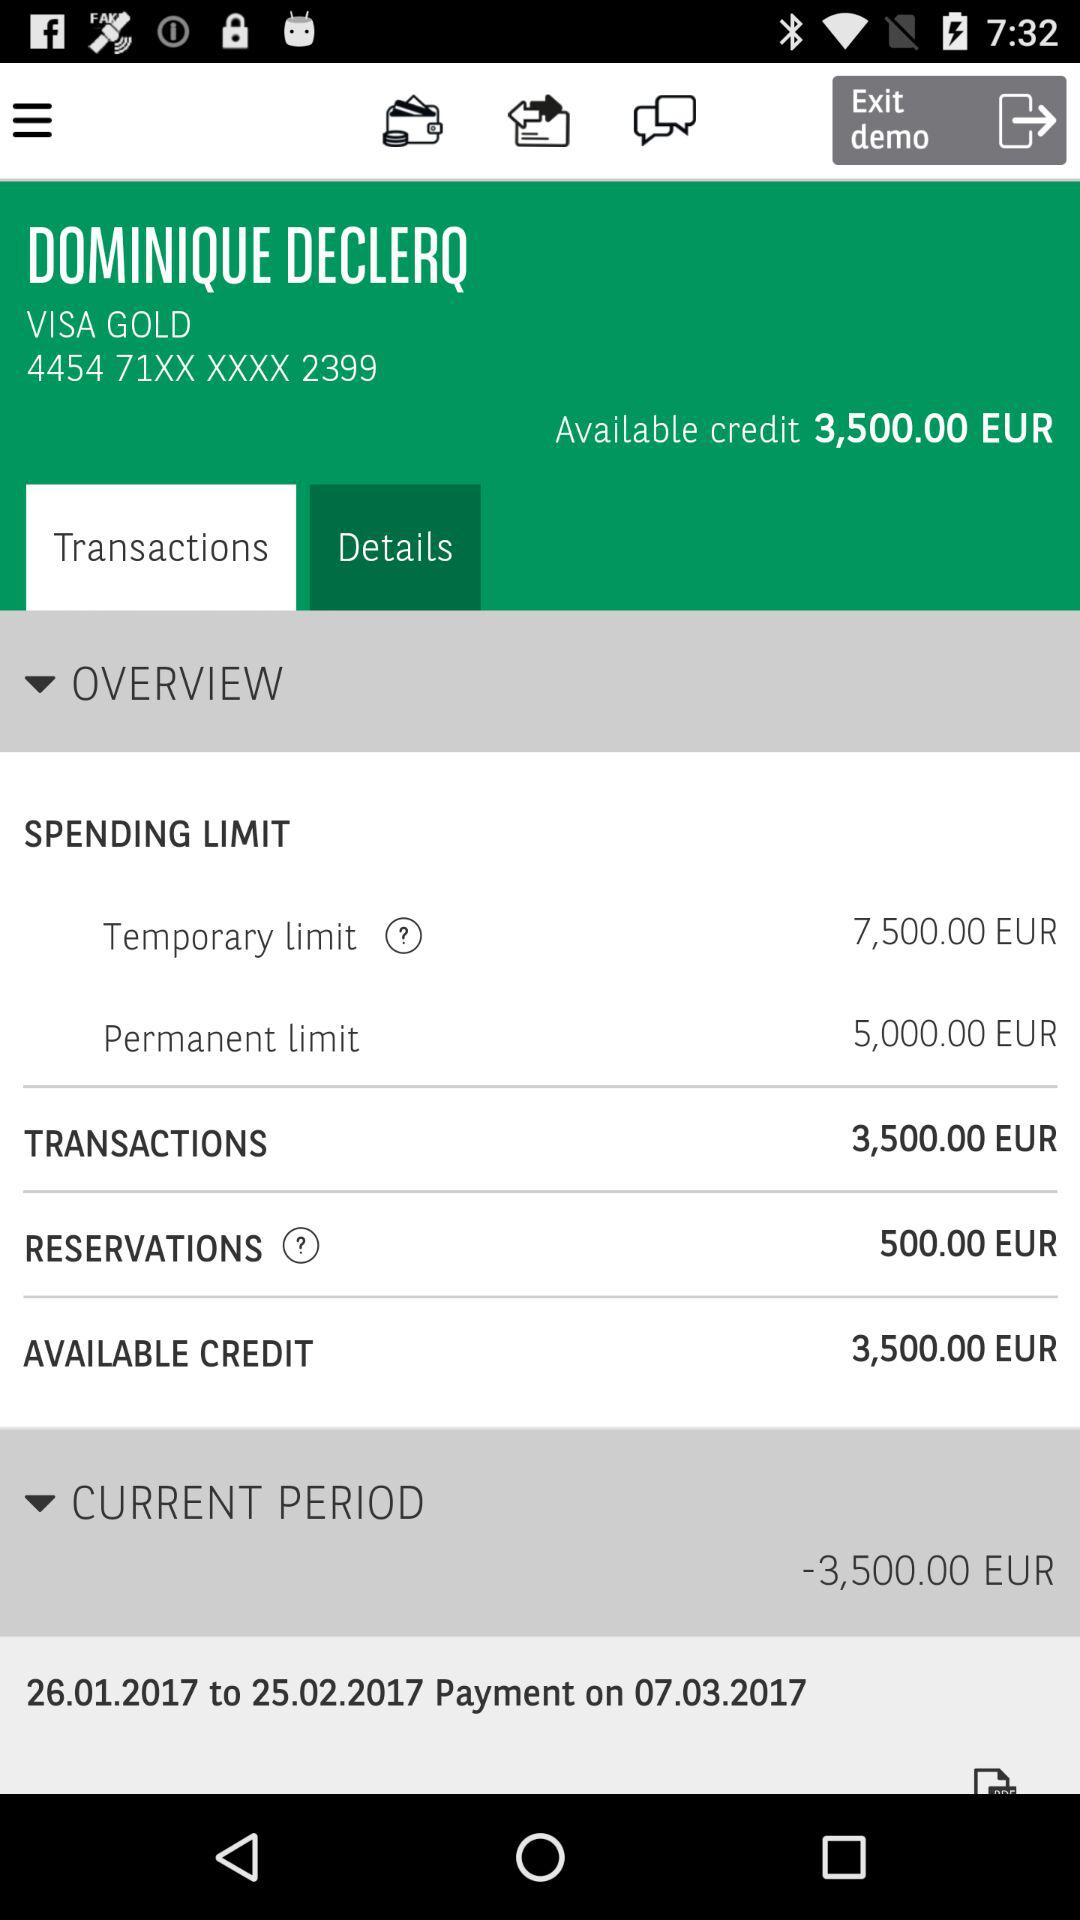On what date was the payment made? The payment was made on July 3, 2017. 